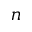Convert formula to latex. <formula><loc_0><loc_0><loc_500><loc_500>n</formula> 